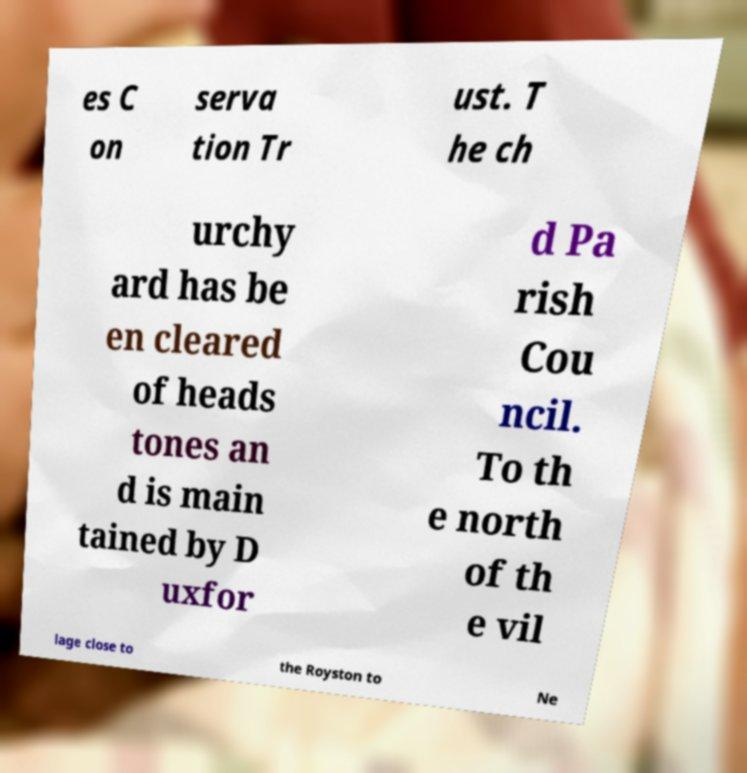For documentation purposes, I need the text within this image transcribed. Could you provide that? es C on serva tion Tr ust. T he ch urchy ard has be en cleared of heads tones an d is main tained by D uxfor d Pa rish Cou ncil. To th e north of th e vil lage close to the Royston to Ne 